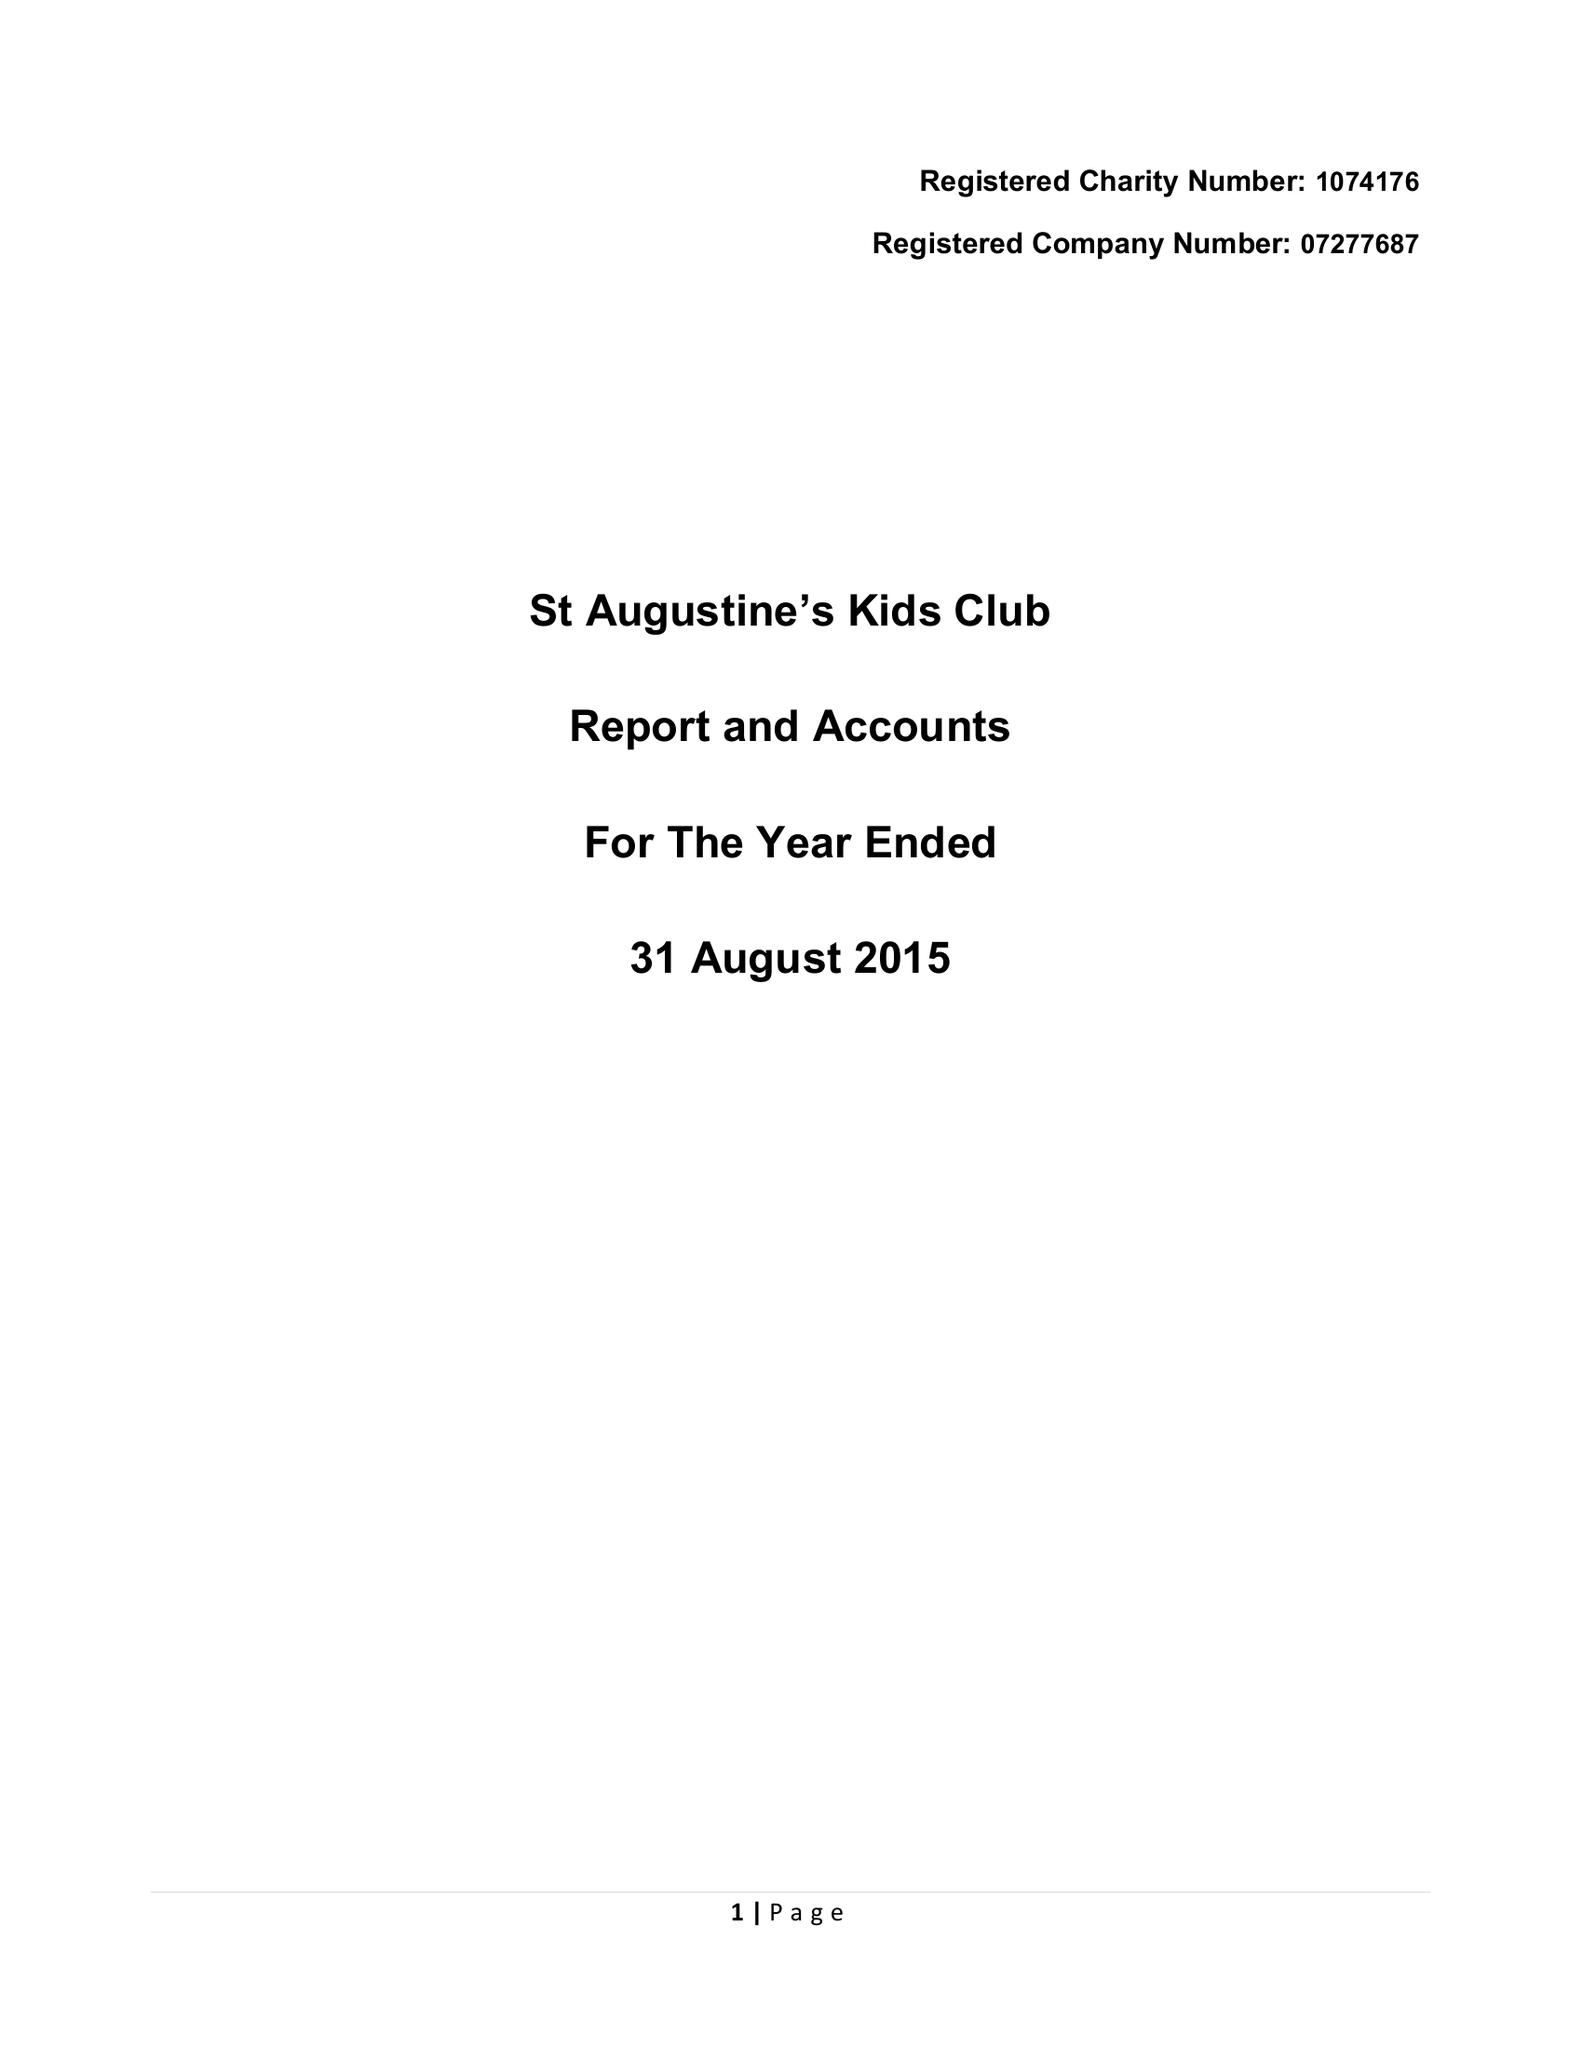What is the value for the spending_annually_in_british_pounds?
Answer the question using a single word or phrase. 180715.00 